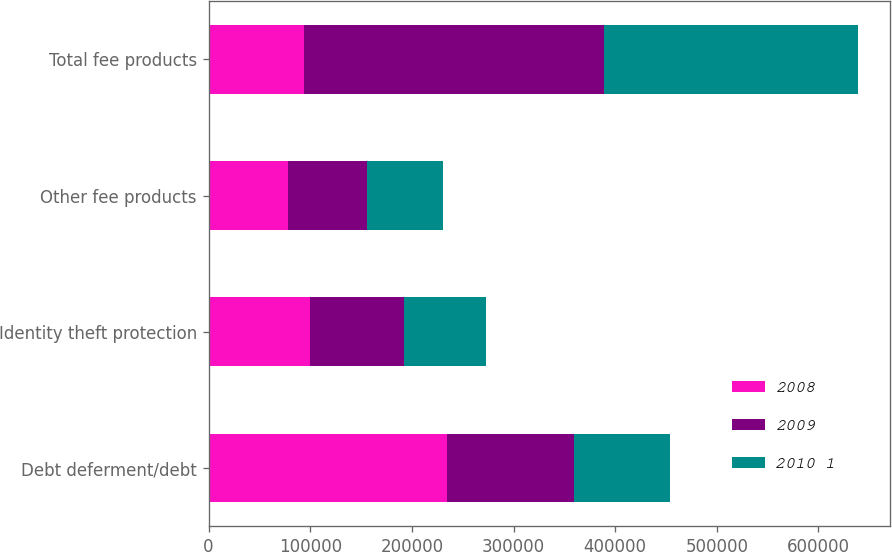Convert chart. <chart><loc_0><loc_0><loc_500><loc_500><stacked_bar_chart><ecel><fcel>Debt deferment/debt<fcel>Identity theft protection<fcel>Other fee products<fcel>Total fee products<nl><fcel>2008<fcel>234158<fcel>99873<fcel>78466<fcel>93835<nl><fcel>2009<fcel>125621<fcel>92557<fcel>76888<fcel>295066<nl><fcel>2010 1<fcel>93835<fcel>80840<fcel>75130<fcel>249805<nl></chart> 